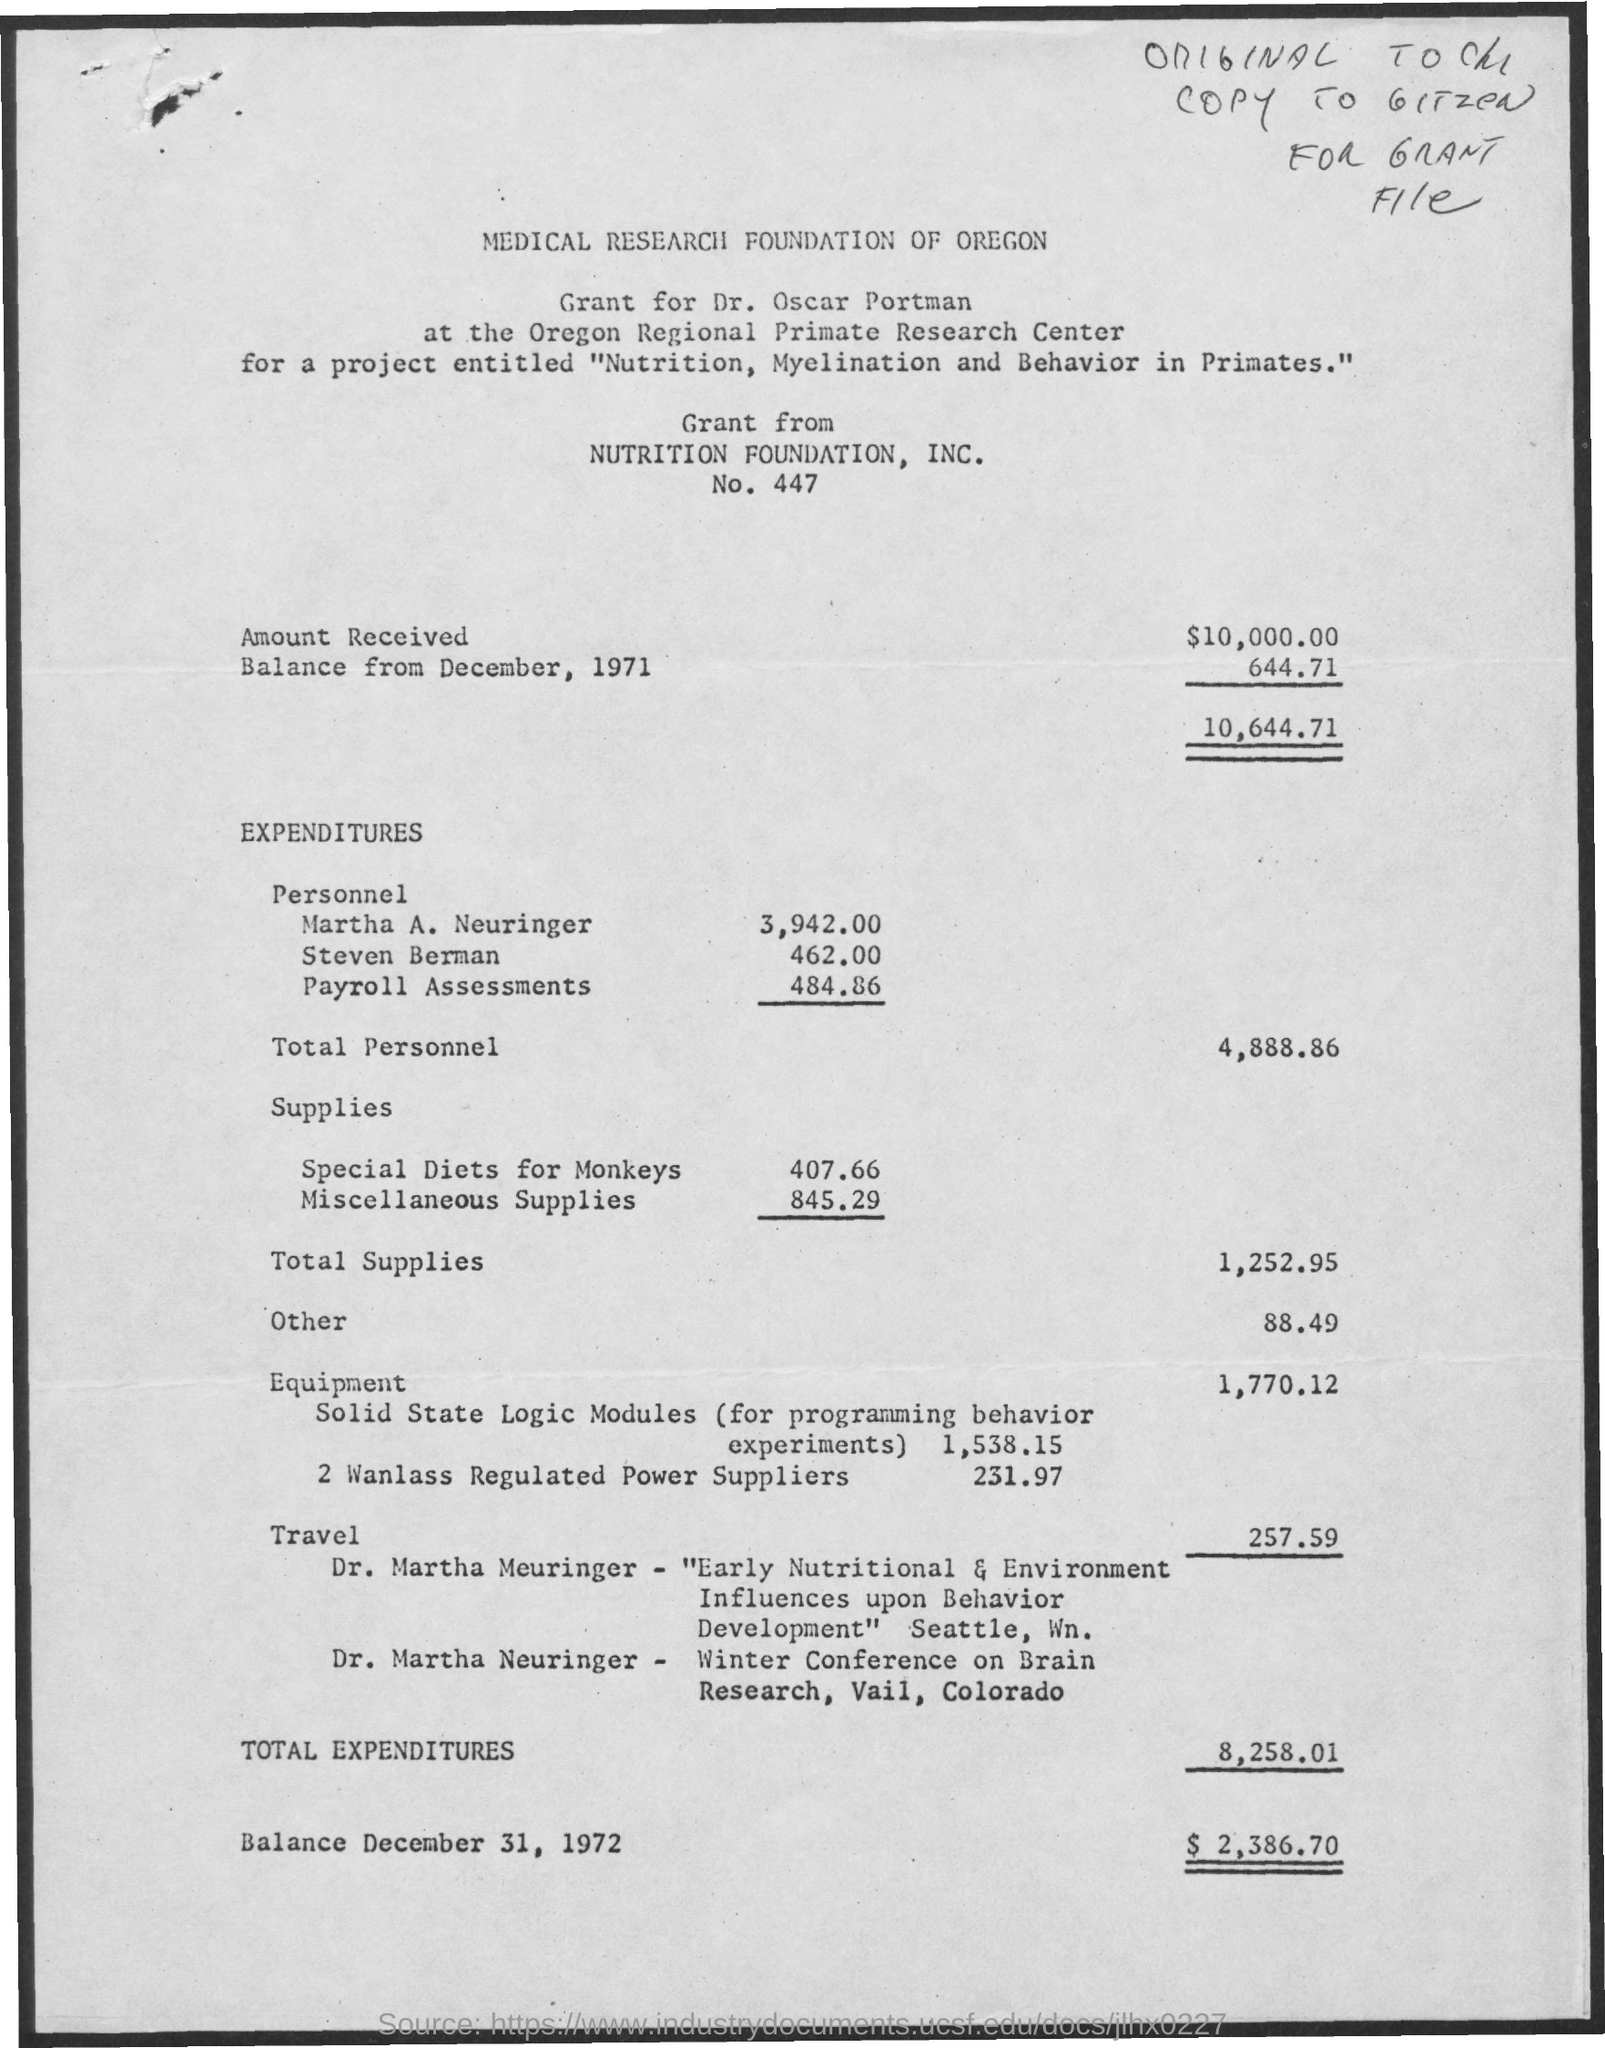List a handful of essential elements in this visual. The Medical Research Foundation of Oregon is mentioned at the top of the page. The grant has been awarded for the project on Nutrition, Myelination, and Behavior in Primates. Dr. Oscar Portman has been awarded a grant. The grant is being provided by the NUTRITION FOUNDATION, INC. 